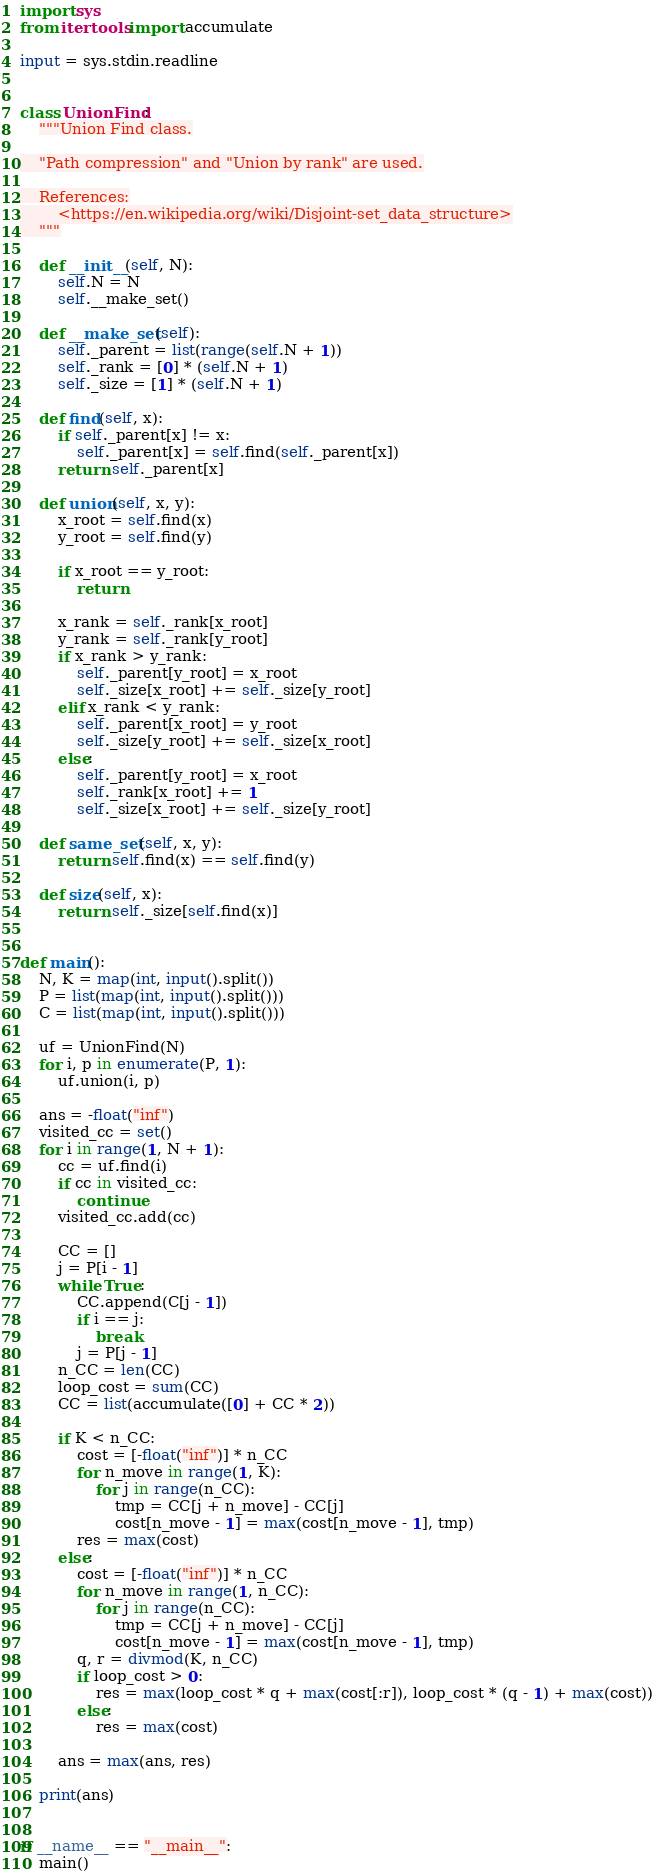<code> <loc_0><loc_0><loc_500><loc_500><_Python_>import sys
from itertools import accumulate

input = sys.stdin.readline


class UnionFind:
    """Union Find class.

    "Path compression" and "Union by rank" are used.

    References:
        <https://en.wikipedia.org/wiki/Disjoint-set_data_structure>
    """

    def __init__(self, N):
        self.N = N
        self.__make_set()

    def __make_set(self):
        self._parent = list(range(self.N + 1))
        self._rank = [0] * (self.N + 1)
        self._size = [1] * (self.N + 1)

    def find(self, x):
        if self._parent[x] != x:
            self._parent[x] = self.find(self._parent[x])
        return self._parent[x]

    def union(self, x, y):
        x_root = self.find(x)
        y_root = self.find(y)

        if x_root == y_root:
            return

        x_rank = self._rank[x_root]
        y_rank = self._rank[y_root]
        if x_rank > y_rank:
            self._parent[y_root] = x_root
            self._size[x_root] += self._size[y_root]
        elif x_rank < y_rank:
            self._parent[x_root] = y_root
            self._size[y_root] += self._size[x_root]
        else:
            self._parent[y_root] = x_root
            self._rank[x_root] += 1
            self._size[x_root] += self._size[y_root]

    def same_set(self, x, y):
        return self.find(x) == self.find(y)

    def size(self, x):
        return self._size[self.find(x)]


def main():
    N, K = map(int, input().split())
    P = list(map(int, input().split()))
    C = list(map(int, input().split()))

    uf = UnionFind(N)
    for i, p in enumerate(P, 1):
        uf.union(i, p)

    ans = -float("inf")
    visited_cc = set()
    for i in range(1, N + 1):
        cc = uf.find(i)
        if cc in visited_cc:
            continue
        visited_cc.add(cc)

        CC = []
        j = P[i - 1]
        while True:
            CC.append(C[j - 1])
            if i == j:
                break
            j = P[j - 1]
        n_CC = len(CC)
        loop_cost = sum(CC)
        CC = list(accumulate([0] + CC * 2))

        if K < n_CC:
            cost = [-float("inf")] * n_CC
            for n_move in range(1, K):
                for j in range(n_CC):
                    tmp = CC[j + n_move] - CC[j]
                    cost[n_move - 1] = max(cost[n_move - 1], tmp)
            res = max(cost)
        else:
            cost = [-float("inf")] * n_CC
            for n_move in range(1, n_CC):
                for j in range(n_CC):
                    tmp = CC[j + n_move] - CC[j]
                    cost[n_move - 1] = max(cost[n_move - 1], tmp)
            q, r = divmod(K, n_CC)
            if loop_cost > 0:
                res = max(loop_cost * q + max(cost[:r]), loop_cost * (q - 1) + max(cost))
            else:
                res = max(cost)

        ans = max(ans, res)

    print(ans)


if __name__ == "__main__":
    main()
</code> 